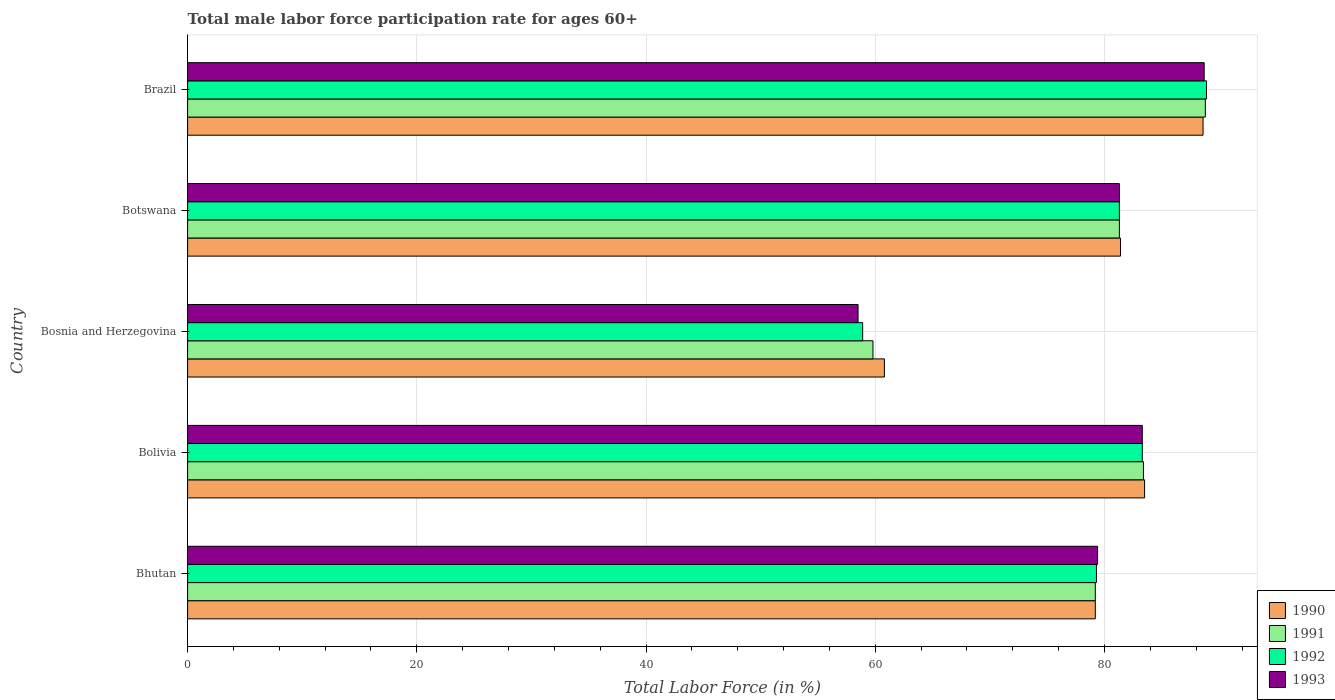How many groups of bars are there?
Ensure brevity in your answer.  5. Are the number of bars on each tick of the Y-axis equal?
Offer a very short reply. Yes. How many bars are there on the 4th tick from the top?
Your answer should be very brief. 4. What is the label of the 2nd group of bars from the top?
Your response must be concise. Botswana. What is the male labor force participation rate in 1993 in Bosnia and Herzegovina?
Offer a terse response. 58.5. Across all countries, what is the maximum male labor force participation rate in 1993?
Give a very brief answer. 88.7. Across all countries, what is the minimum male labor force participation rate in 1992?
Offer a very short reply. 58.9. In which country was the male labor force participation rate in 1993 maximum?
Your answer should be very brief. Brazil. In which country was the male labor force participation rate in 1990 minimum?
Make the answer very short. Bosnia and Herzegovina. What is the total male labor force participation rate in 1993 in the graph?
Your answer should be compact. 391.2. What is the difference between the male labor force participation rate in 1992 in Bhutan and that in Botswana?
Give a very brief answer. -2. What is the average male labor force participation rate in 1990 per country?
Provide a short and direct response. 78.7. What is the difference between the male labor force participation rate in 1990 and male labor force participation rate in 1991 in Bolivia?
Provide a short and direct response. 0.1. What is the ratio of the male labor force participation rate in 1992 in Bolivia to that in Botswana?
Your response must be concise. 1.02. What is the difference between the highest and the second highest male labor force participation rate in 1992?
Give a very brief answer. 5.6. What is the difference between the highest and the lowest male labor force participation rate in 1993?
Offer a very short reply. 30.2. In how many countries, is the male labor force participation rate in 1991 greater than the average male labor force participation rate in 1991 taken over all countries?
Offer a terse response. 4. What does the 1st bar from the top in Brazil represents?
Keep it short and to the point. 1993. What does the 2nd bar from the bottom in Botswana represents?
Make the answer very short. 1991. Is it the case that in every country, the sum of the male labor force participation rate in 1992 and male labor force participation rate in 1991 is greater than the male labor force participation rate in 1993?
Your answer should be compact. Yes. How many bars are there?
Your response must be concise. 20. Are all the bars in the graph horizontal?
Your response must be concise. Yes. Are the values on the major ticks of X-axis written in scientific E-notation?
Ensure brevity in your answer.  No. Does the graph contain any zero values?
Your answer should be compact. No. Does the graph contain grids?
Ensure brevity in your answer.  Yes. Where does the legend appear in the graph?
Provide a short and direct response. Bottom right. What is the title of the graph?
Provide a succinct answer. Total male labor force participation rate for ages 60+. What is the label or title of the X-axis?
Offer a very short reply. Total Labor Force (in %). What is the label or title of the Y-axis?
Make the answer very short. Country. What is the Total Labor Force (in %) of 1990 in Bhutan?
Make the answer very short. 79.2. What is the Total Labor Force (in %) in 1991 in Bhutan?
Provide a succinct answer. 79.2. What is the Total Labor Force (in %) of 1992 in Bhutan?
Your answer should be very brief. 79.3. What is the Total Labor Force (in %) of 1993 in Bhutan?
Offer a terse response. 79.4. What is the Total Labor Force (in %) of 1990 in Bolivia?
Keep it short and to the point. 83.5. What is the Total Labor Force (in %) in 1991 in Bolivia?
Provide a succinct answer. 83.4. What is the Total Labor Force (in %) of 1992 in Bolivia?
Keep it short and to the point. 83.3. What is the Total Labor Force (in %) of 1993 in Bolivia?
Make the answer very short. 83.3. What is the Total Labor Force (in %) in 1990 in Bosnia and Herzegovina?
Offer a terse response. 60.8. What is the Total Labor Force (in %) in 1991 in Bosnia and Herzegovina?
Make the answer very short. 59.8. What is the Total Labor Force (in %) of 1992 in Bosnia and Herzegovina?
Offer a terse response. 58.9. What is the Total Labor Force (in %) in 1993 in Bosnia and Herzegovina?
Ensure brevity in your answer.  58.5. What is the Total Labor Force (in %) of 1990 in Botswana?
Your answer should be compact. 81.4. What is the Total Labor Force (in %) in 1991 in Botswana?
Provide a short and direct response. 81.3. What is the Total Labor Force (in %) in 1992 in Botswana?
Your answer should be compact. 81.3. What is the Total Labor Force (in %) of 1993 in Botswana?
Provide a short and direct response. 81.3. What is the Total Labor Force (in %) in 1990 in Brazil?
Your answer should be very brief. 88.6. What is the Total Labor Force (in %) of 1991 in Brazil?
Offer a terse response. 88.8. What is the Total Labor Force (in %) of 1992 in Brazil?
Your response must be concise. 88.9. What is the Total Labor Force (in %) of 1993 in Brazil?
Your answer should be compact. 88.7. Across all countries, what is the maximum Total Labor Force (in %) in 1990?
Offer a terse response. 88.6. Across all countries, what is the maximum Total Labor Force (in %) in 1991?
Provide a short and direct response. 88.8. Across all countries, what is the maximum Total Labor Force (in %) of 1992?
Your response must be concise. 88.9. Across all countries, what is the maximum Total Labor Force (in %) in 1993?
Keep it short and to the point. 88.7. Across all countries, what is the minimum Total Labor Force (in %) in 1990?
Your answer should be compact. 60.8. Across all countries, what is the minimum Total Labor Force (in %) of 1991?
Ensure brevity in your answer.  59.8. Across all countries, what is the minimum Total Labor Force (in %) of 1992?
Your answer should be compact. 58.9. Across all countries, what is the minimum Total Labor Force (in %) in 1993?
Make the answer very short. 58.5. What is the total Total Labor Force (in %) of 1990 in the graph?
Provide a succinct answer. 393.5. What is the total Total Labor Force (in %) of 1991 in the graph?
Make the answer very short. 392.5. What is the total Total Labor Force (in %) in 1992 in the graph?
Ensure brevity in your answer.  391.7. What is the total Total Labor Force (in %) in 1993 in the graph?
Give a very brief answer. 391.2. What is the difference between the Total Labor Force (in %) in 1993 in Bhutan and that in Bolivia?
Make the answer very short. -3.9. What is the difference between the Total Labor Force (in %) of 1992 in Bhutan and that in Bosnia and Herzegovina?
Provide a short and direct response. 20.4. What is the difference between the Total Labor Force (in %) in 1993 in Bhutan and that in Bosnia and Herzegovina?
Keep it short and to the point. 20.9. What is the difference between the Total Labor Force (in %) of 1992 in Bhutan and that in Botswana?
Your response must be concise. -2. What is the difference between the Total Labor Force (in %) of 1993 in Bhutan and that in Botswana?
Provide a short and direct response. -1.9. What is the difference between the Total Labor Force (in %) in 1990 in Bhutan and that in Brazil?
Give a very brief answer. -9.4. What is the difference between the Total Labor Force (in %) in 1991 in Bhutan and that in Brazil?
Provide a short and direct response. -9.6. What is the difference between the Total Labor Force (in %) of 1992 in Bhutan and that in Brazil?
Your answer should be compact. -9.6. What is the difference between the Total Labor Force (in %) of 1993 in Bhutan and that in Brazil?
Provide a succinct answer. -9.3. What is the difference between the Total Labor Force (in %) in 1990 in Bolivia and that in Bosnia and Herzegovina?
Make the answer very short. 22.7. What is the difference between the Total Labor Force (in %) in 1991 in Bolivia and that in Bosnia and Herzegovina?
Offer a terse response. 23.6. What is the difference between the Total Labor Force (in %) of 1992 in Bolivia and that in Bosnia and Herzegovina?
Offer a terse response. 24.4. What is the difference between the Total Labor Force (in %) in 1993 in Bolivia and that in Bosnia and Herzegovina?
Your answer should be compact. 24.8. What is the difference between the Total Labor Force (in %) of 1991 in Bolivia and that in Botswana?
Provide a short and direct response. 2.1. What is the difference between the Total Labor Force (in %) in 1993 in Bolivia and that in Botswana?
Give a very brief answer. 2. What is the difference between the Total Labor Force (in %) in 1990 in Bolivia and that in Brazil?
Your answer should be very brief. -5.1. What is the difference between the Total Labor Force (in %) of 1992 in Bolivia and that in Brazil?
Offer a very short reply. -5.6. What is the difference between the Total Labor Force (in %) in 1990 in Bosnia and Herzegovina and that in Botswana?
Ensure brevity in your answer.  -20.6. What is the difference between the Total Labor Force (in %) in 1991 in Bosnia and Herzegovina and that in Botswana?
Provide a short and direct response. -21.5. What is the difference between the Total Labor Force (in %) of 1992 in Bosnia and Herzegovina and that in Botswana?
Provide a succinct answer. -22.4. What is the difference between the Total Labor Force (in %) of 1993 in Bosnia and Herzegovina and that in Botswana?
Your answer should be very brief. -22.8. What is the difference between the Total Labor Force (in %) in 1990 in Bosnia and Herzegovina and that in Brazil?
Offer a very short reply. -27.8. What is the difference between the Total Labor Force (in %) in 1993 in Bosnia and Herzegovina and that in Brazil?
Your answer should be compact. -30.2. What is the difference between the Total Labor Force (in %) in 1990 in Bhutan and the Total Labor Force (in %) in 1992 in Bolivia?
Ensure brevity in your answer.  -4.1. What is the difference between the Total Labor Force (in %) in 1990 in Bhutan and the Total Labor Force (in %) in 1993 in Bolivia?
Offer a terse response. -4.1. What is the difference between the Total Labor Force (in %) in 1992 in Bhutan and the Total Labor Force (in %) in 1993 in Bolivia?
Your answer should be compact. -4. What is the difference between the Total Labor Force (in %) of 1990 in Bhutan and the Total Labor Force (in %) of 1991 in Bosnia and Herzegovina?
Give a very brief answer. 19.4. What is the difference between the Total Labor Force (in %) of 1990 in Bhutan and the Total Labor Force (in %) of 1992 in Bosnia and Herzegovina?
Provide a succinct answer. 20.3. What is the difference between the Total Labor Force (in %) in 1990 in Bhutan and the Total Labor Force (in %) in 1993 in Bosnia and Herzegovina?
Provide a succinct answer. 20.7. What is the difference between the Total Labor Force (in %) of 1991 in Bhutan and the Total Labor Force (in %) of 1992 in Bosnia and Herzegovina?
Provide a short and direct response. 20.3. What is the difference between the Total Labor Force (in %) of 1991 in Bhutan and the Total Labor Force (in %) of 1993 in Bosnia and Herzegovina?
Offer a terse response. 20.7. What is the difference between the Total Labor Force (in %) of 1992 in Bhutan and the Total Labor Force (in %) of 1993 in Bosnia and Herzegovina?
Give a very brief answer. 20.8. What is the difference between the Total Labor Force (in %) of 1990 in Bhutan and the Total Labor Force (in %) of 1991 in Botswana?
Give a very brief answer. -2.1. What is the difference between the Total Labor Force (in %) in 1991 in Bhutan and the Total Labor Force (in %) in 1992 in Botswana?
Keep it short and to the point. -2.1. What is the difference between the Total Labor Force (in %) of 1991 in Bhutan and the Total Labor Force (in %) of 1993 in Botswana?
Your response must be concise. -2.1. What is the difference between the Total Labor Force (in %) of 1990 in Bhutan and the Total Labor Force (in %) of 1992 in Brazil?
Make the answer very short. -9.7. What is the difference between the Total Labor Force (in %) in 1990 in Bhutan and the Total Labor Force (in %) in 1993 in Brazil?
Keep it short and to the point. -9.5. What is the difference between the Total Labor Force (in %) of 1991 in Bhutan and the Total Labor Force (in %) of 1992 in Brazil?
Your answer should be very brief. -9.7. What is the difference between the Total Labor Force (in %) of 1991 in Bhutan and the Total Labor Force (in %) of 1993 in Brazil?
Provide a short and direct response. -9.5. What is the difference between the Total Labor Force (in %) in 1990 in Bolivia and the Total Labor Force (in %) in 1991 in Bosnia and Herzegovina?
Your answer should be compact. 23.7. What is the difference between the Total Labor Force (in %) of 1990 in Bolivia and the Total Labor Force (in %) of 1992 in Bosnia and Herzegovina?
Give a very brief answer. 24.6. What is the difference between the Total Labor Force (in %) of 1991 in Bolivia and the Total Labor Force (in %) of 1993 in Bosnia and Herzegovina?
Offer a very short reply. 24.9. What is the difference between the Total Labor Force (in %) in 1992 in Bolivia and the Total Labor Force (in %) in 1993 in Bosnia and Herzegovina?
Make the answer very short. 24.8. What is the difference between the Total Labor Force (in %) in 1991 in Bolivia and the Total Labor Force (in %) in 1992 in Botswana?
Offer a terse response. 2.1. What is the difference between the Total Labor Force (in %) of 1991 in Bolivia and the Total Labor Force (in %) of 1993 in Botswana?
Your answer should be compact. 2.1. What is the difference between the Total Labor Force (in %) of 1990 in Bolivia and the Total Labor Force (in %) of 1991 in Brazil?
Your response must be concise. -5.3. What is the difference between the Total Labor Force (in %) in 1990 in Bolivia and the Total Labor Force (in %) in 1993 in Brazil?
Your answer should be very brief. -5.2. What is the difference between the Total Labor Force (in %) in 1992 in Bolivia and the Total Labor Force (in %) in 1993 in Brazil?
Provide a succinct answer. -5.4. What is the difference between the Total Labor Force (in %) of 1990 in Bosnia and Herzegovina and the Total Labor Force (in %) of 1991 in Botswana?
Your answer should be compact. -20.5. What is the difference between the Total Labor Force (in %) of 1990 in Bosnia and Herzegovina and the Total Labor Force (in %) of 1992 in Botswana?
Offer a very short reply. -20.5. What is the difference between the Total Labor Force (in %) in 1990 in Bosnia and Herzegovina and the Total Labor Force (in %) in 1993 in Botswana?
Your response must be concise. -20.5. What is the difference between the Total Labor Force (in %) of 1991 in Bosnia and Herzegovina and the Total Labor Force (in %) of 1992 in Botswana?
Offer a very short reply. -21.5. What is the difference between the Total Labor Force (in %) in 1991 in Bosnia and Herzegovina and the Total Labor Force (in %) in 1993 in Botswana?
Offer a terse response. -21.5. What is the difference between the Total Labor Force (in %) in 1992 in Bosnia and Herzegovina and the Total Labor Force (in %) in 1993 in Botswana?
Make the answer very short. -22.4. What is the difference between the Total Labor Force (in %) in 1990 in Bosnia and Herzegovina and the Total Labor Force (in %) in 1992 in Brazil?
Provide a succinct answer. -28.1. What is the difference between the Total Labor Force (in %) of 1990 in Bosnia and Herzegovina and the Total Labor Force (in %) of 1993 in Brazil?
Ensure brevity in your answer.  -27.9. What is the difference between the Total Labor Force (in %) in 1991 in Bosnia and Herzegovina and the Total Labor Force (in %) in 1992 in Brazil?
Ensure brevity in your answer.  -29.1. What is the difference between the Total Labor Force (in %) in 1991 in Bosnia and Herzegovina and the Total Labor Force (in %) in 1993 in Brazil?
Provide a succinct answer. -28.9. What is the difference between the Total Labor Force (in %) in 1992 in Bosnia and Herzegovina and the Total Labor Force (in %) in 1993 in Brazil?
Provide a short and direct response. -29.8. What is the difference between the Total Labor Force (in %) of 1990 in Botswana and the Total Labor Force (in %) of 1991 in Brazil?
Your answer should be very brief. -7.4. What is the difference between the Total Labor Force (in %) in 1990 in Botswana and the Total Labor Force (in %) in 1993 in Brazil?
Give a very brief answer. -7.3. What is the difference between the Total Labor Force (in %) of 1992 in Botswana and the Total Labor Force (in %) of 1993 in Brazil?
Provide a short and direct response. -7.4. What is the average Total Labor Force (in %) in 1990 per country?
Give a very brief answer. 78.7. What is the average Total Labor Force (in %) of 1991 per country?
Provide a succinct answer. 78.5. What is the average Total Labor Force (in %) in 1992 per country?
Offer a very short reply. 78.34. What is the average Total Labor Force (in %) in 1993 per country?
Give a very brief answer. 78.24. What is the difference between the Total Labor Force (in %) of 1990 and Total Labor Force (in %) of 1992 in Bhutan?
Provide a short and direct response. -0.1. What is the difference between the Total Labor Force (in %) in 1990 and Total Labor Force (in %) in 1993 in Bhutan?
Offer a very short reply. -0.2. What is the difference between the Total Labor Force (in %) in 1990 and Total Labor Force (in %) in 1993 in Bolivia?
Make the answer very short. 0.2. What is the difference between the Total Labor Force (in %) in 1991 and Total Labor Force (in %) in 1992 in Bolivia?
Your answer should be compact. 0.1. What is the difference between the Total Labor Force (in %) of 1991 and Total Labor Force (in %) of 1993 in Bolivia?
Offer a very short reply. 0.1. What is the difference between the Total Labor Force (in %) of 1992 and Total Labor Force (in %) of 1993 in Bolivia?
Ensure brevity in your answer.  0. What is the difference between the Total Labor Force (in %) of 1990 and Total Labor Force (in %) of 1991 in Bosnia and Herzegovina?
Your answer should be compact. 1. What is the difference between the Total Labor Force (in %) of 1990 and Total Labor Force (in %) of 1992 in Bosnia and Herzegovina?
Your answer should be very brief. 1.9. What is the difference between the Total Labor Force (in %) of 1990 and Total Labor Force (in %) of 1993 in Bosnia and Herzegovina?
Provide a short and direct response. 2.3. What is the difference between the Total Labor Force (in %) in 1991 and Total Labor Force (in %) in 1992 in Bosnia and Herzegovina?
Offer a very short reply. 0.9. What is the difference between the Total Labor Force (in %) of 1991 and Total Labor Force (in %) of 1993 in Bosnia and Herzegovina?
Your answer should be compact. 1.3. What is the difference between the Total Labor Force (in %) in 1992 and Total Labor Force (in %) in 1993 in Bosnia and Herzegovina?
Your answer should be very brief. 0.4. What is the difference between the Total Labor Force (in %) of 1990 and Total Labor Force (in %) of 1991 in Botswana?
Your response must be concise. 0.1. What is the difference between the Total Labor Force (in %) in 1990 and Total Labor Force (in %) in 1992 in Botswana?
Make the answer very short. 0.1. What is the difference between the Total Labor Force (in %) in 1991 and Total Labor Force (in %) in 1992 in Botswana?
Your response must be concise. 0. What is the difference between the Total Labor Force (in %) of 1992 and Total Labor Force (in %) of 1993 in Botswana?
Give a very brief answer. 0. What is the difference between the Total Labor Force (in %) in 1990 and Total Labor Force (in %) in 1991 in Brazil?
Your answer should be compact. -0.2. What is the difference between the Total Labor Force (in %) in 1990 and Total Labor Force (in %) in 1992 in Brazil?
Give a very brief answer. -0.3. What is the difference between the Total Labor Force (in %) in 1991 and Total Labor Force (in %) in 1992 in Brazil?
Make the answer very short. -0.1. What is the difference between the Total Labor Force (in %) of 1991 and Total Labor Force (in %) of 1993 in Brazil?
Keep it short and to the point. 0.1. What is the difference between the Total Labor Force (in %) of 1992 and Total Labor Force (in %) of 1993 in Brazil?
Provide a succinct answer. 0.2. What is the ratio of the Total Labor Force (in %) in 1990 in Bhutan to that in Bolivia?
Make the answer very short. 0.95. What is the ratio of the Total Labor Force (in %) in 1991 in Bhutan to that in Bolivia?
Keep it short and to the point. 0.95. What is the ratio of the Total Labor Force (in %) in 1993 in Bhutan to that in Bolivia?
Your answer should be very brief. 0.95. What is the ratio of the Total Labor Force (in %) in 1990 in Bhutan to that in Bosnia and Herzegovina?
Make the answer very short. 1.3. What is the ratio of the Total Labor Force (in %) of 1991 in Bhutan to that in Bosnia and Herzegovina?
Your answer should be very brief. 1.32. What is the ratio of the Total Labor Force (in %) in 1992 in Bhutan to that in Bosnia and Herzegovina?
Offer a very short reply. 1.35. What is the ratio of the Total Labor Force (in %) of 1993 in Bhutan to that in Bosnia and Herzegovina?
Keep it short and to the point. 1.36. What is the ratio of the Total Labor Force (in %) in 1990 in Bhutan to that in Botswana?
Offer a terse response. 0.97. What is the ratio of the Total Labor Force (in %) in 1991 in Bhutan to that in Botswana?
Provide a short and direct response. 0.97. What is the ratio of the Total Labor Force (in %) of 1992 in Bhutan to that in Botswana?
Make the answer very short. 0.98. What is the ratio of the Total Labor Force (in %) of 1993 in Bhutan to that in Botswana?
Your answer should be compact. 0.98. What is the ratio of the Total Labor Force (in %) of 1990 in Bhutan to that in Brazil?
Your answer should be compact. 0.89. What is the ratio of the Total Labor Force (in %) of 1991 in Bhutan to that in Brazil?
Offer a terse response. 0.89. What is the ratio of the Total Labor Force (in %) in 1992 in Bhutan to that in Brazil?
Keep it short and to the point. 0.89. What is the ratio of the Total Labor Force (in %) of 1993 in Bhutan to that in Brazil?
Offer a very short reply. 0.9. What is the ratio of the Total Labor Force (in %) in 1990 in Bolivia to that in Bosnia and Herzegovina?
Make the answer very short. 1.37. What is the ratio of the Total Labor Force (in %) of 1991 in Bolivia to that in Bosnia and Herzegovina?
Give a very brief answer. 1.39. What is the ratio of the Total Labor Force (in %) of 1992 in Bolivia to that in Bosnia and Herzegovina?
Make the answer very short. 1.41. What is the ratio of the Total Labor Force (in %) in 1993 in Bolivia to that in Bosnia and Herzegovina?
Keep it short and to the point. 1.42. What is the ratio of the Total Labor Force (in %) of 1990 in Bolivia to that in Botswana?
Provide a succinct answer. 1.03. What is the ratio of the Total Labor Force (in %) in 1991 in Bolivia to that in Botswana?
Your answer should be compact. 1.03. What is the ratio of the Total Labor Force (in %) in 1992 in Bolivia to that in Botswana?
Ensure brevity in your answer.  1.02. What is the ratio of the Total Labor Force (in %) of 1993 in Bolivia to that in Botswana?
Provide a succinct answer. 1.02. What is the ratio of the Total Labor Force (in %) in 1990 in Bolivia to that in Brazil?
Your response must be concise. 0.94. What is the ratio of the Total Labor Force (in %) in 1991 in Bolivia to that in Brazil?
Give a very brief answer. 0.94. What is the ratio of the Total Labor Force (in %) of 1992 in Bolivia to that in Brazil?
Ensure brevity in your answer.  0.94. What is the ratio of the Total Labor Force (in %) of 1993 in Bolivia to that in Brazil?
Offer a very short reply. 0.94. What is the ratio of the Total Labor Force (in %) of 1990 in Bosnia and Herzegovina to that in Botswana?
Give a very brief answer. 0.75. What is the ratio of the Total Labor Force (in %) of 1991 in Bosnia and Herzegovina to that in Botswana?
Provide a succinct answer. 0.74. What is the ratio of the Total Labor Force (in %) in 1992 in Bosnia and Herzegovina to that in Botswana?
Provide a short and direct response. 0.72. What is the ratio of the Total Labor Force (in %) of 1993 in Bosnia and Herzegovina to that in Botswana?
Ensure brevity in your answer.  0.72. What is the ratio of the Total Labor Force (in %) of 1990 in Bosnia and Herzegovina to that in Brazil?
Keep it short and to the point. 0.69. What is the ratio of the Total Labor Force (in %) in 1991 in Bosnia and Herzegovina to that in Brazil?
Give a very brief answer. 0.67. What is the ratio of the Total Labor Force (in %) of 1992 in Bosnia and Herzegovina to that in Brazil?
Your answer should be very brief. 0.66. What is the ratio of the Total Labor Force (in %) of 1993 in Bosnia and Herzegovina to that in Brazil?
Your answer should be compact. 0.66. What is the ratio of the Total Labor Force (in %) of 1990 in Botswana to that in Brazil?
Keep it short and to the point. 0.92. What is the ratio of the Total Labor Force (in %) of 1991 in Botswana to that in Brazil?
Keep it short and to the point. 0.92. What is the ratio of the Total Labor Force (in %) in 1992 in Botswana to that in Brazil?
Give a very brief answer. 0.91. What is the ratio of the Total Labor Force (in %) of 1993 in Botswana to that in Brazil?
Offer a terse response. 0.92. What is the difference between the highest and the second highest Total Labor Force (in %) of 1990?
Offer a terse response. 5.1. What is the difference between the highest and the second highest Total Labor Force (in %) in 1992?
Your answer should be compact. 5.6. What is the difference between the highest and the lowest Total Labor Force (in %) of 1990?
Your response must be concise. 27.8. What is the difference between the highest and the lowest Total Labor Force (in %) of 1993?
Ensure brevity in your answer.  30.2. 